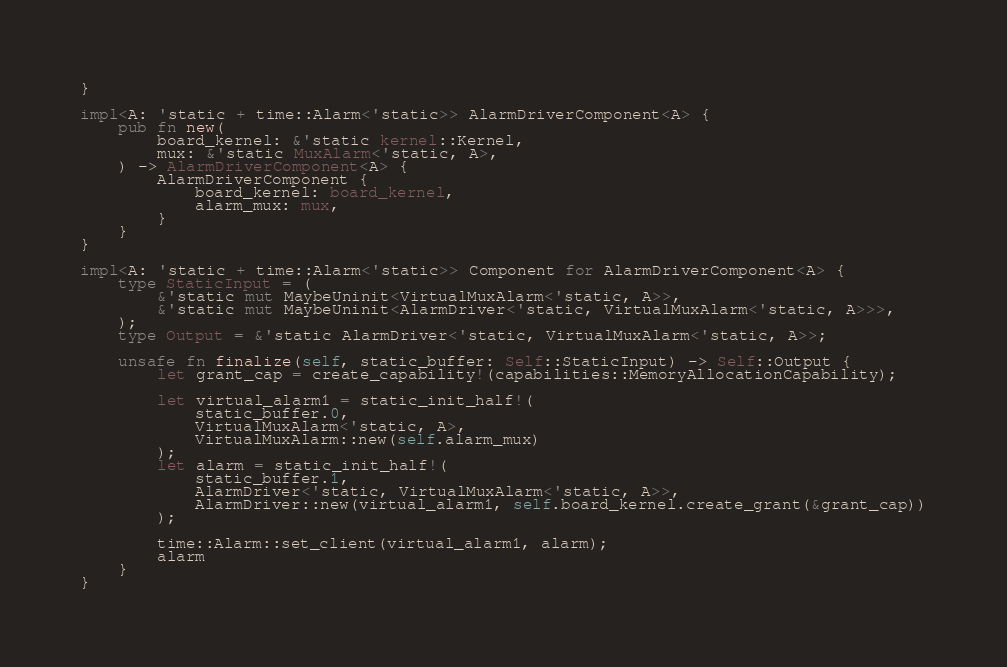<code> <loc_0><loc_0><loc_500><loc_500><_Rust_>}

impl<A: 'static + time::Alarm<'static>> AlarmDriverComponent<A> {
    pub fn new(
        board_kernel: &'static kernel::Kernel,
        mux: &'static MuxAlarm<'static, A>,
    ) -> AlarmDriverComponent<A> {
        AlarmDriverComponent {
            board_kernel: board_kernel,
            alarm_mux: mux,
        }
    }
}

impl<A: 'static + time::Alarm<'static>> Component for AlarmDriverComponent<A> {
    type StaticInput = (
        &'static mut MaybeUninit<VirtualMuxAlarm<'static, A>>,
        &'static mut MaybeUninit<AlarmDriver<'static, VirtualMuxAlarm<'static, A>>>,
    );
    type Output = &'static AlarmDriver<'static, VirtualMuxAlarm<'static, A>>;

    unsafe fn finalize(self, static_buffer: Self::StaticInput) -> Self::Output {
        let grant_cap = create_capability!(capabilities::MemoryAllocationCapability);

        let virtual_alarm1 = static_init_half!(
            static_buffer.0,
            VirtualMuxAlarm<'static, A>,
            VirtualMuxAlarm::new(self.alarm_mux)
        );
        let alarm = static_init_half!(
            static_buffer.1,
            AlarmDriver<'static, VirtualMuxAlarm<'static, A>>,
            AlarmDriver::new(virtual_alarm1, self.board_kernel.create_grant(&grant_cap))
        );

        time::Alarm::set_client(virtual_alarm1, alarm);
        alarm
    }
}
</code> 